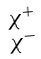Convert formula to latex. <formula><loc_0><loc_0><loc_500><loc_500>\begin{smallmatrix} \chi ^ { + } \\ \chi ^ { - } \end{smallmatrix}</formula> 